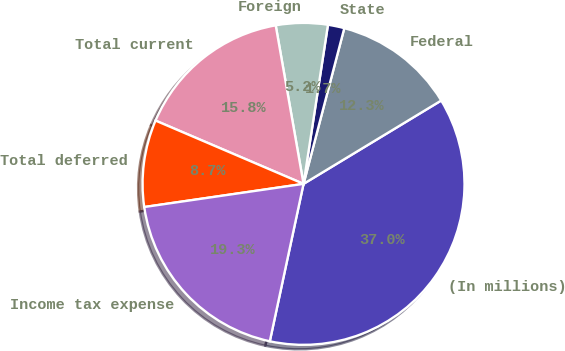<chart> <loc_0><loc_0><loc_500><loc_500><pie_chart><fcel>(In millions)<fcel>Federal<fcel>State<fcel>Foreign<fcel>Total current<fcel>Total deferred<fcel>Income tax expense<nl><fcel>37.02%<fcel>12.26%<fcel>1.65%<fcel>5.19%<fcel>15.8%<fcel>8.73%<fcel>19.34%<nl></chart> 